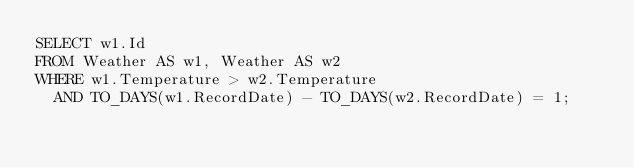<code> <loc_0><loc_0><loc_500><loc_500><_SQL_>SELECT w1.Id
FROM Weather AS w1, Weather AS w2
WHERE w1.Temperature > w2.Temperature
  AND TO_DAYS(w1.RecordDate) - TO_DAYS(w2.RecordDate) = 1;
</code> 